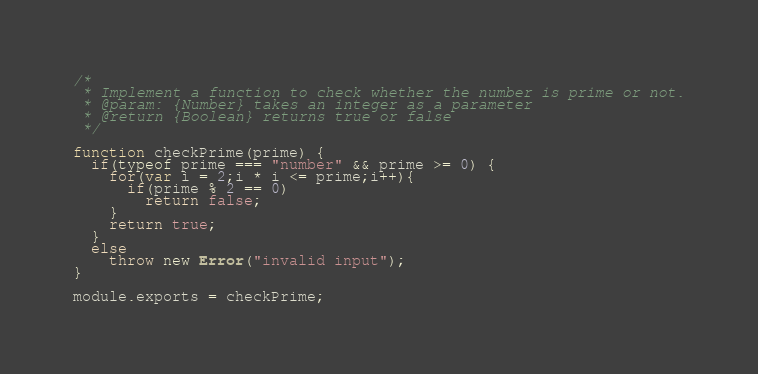Convert code to text. <code><loc_0><loc_0><loc_500><loc_500><_JavaScript_>/*
 * Implement a function to check whether the number is prime or not.
 * @param: {Number} takes an integer as a parameter
 * @return {Boolean} returns true or false
 */

function checkPrime(prime) {
  if(typeof prime === "number" && prime >= 0) {
    for(var i = 2;i * i <= prime;i++){
      if(prime % 2 == 0)
        return false;
    }
    return true;
  }
  else
    throw new Error("invalid input");
}

module.exports = checkPrime;</code> 